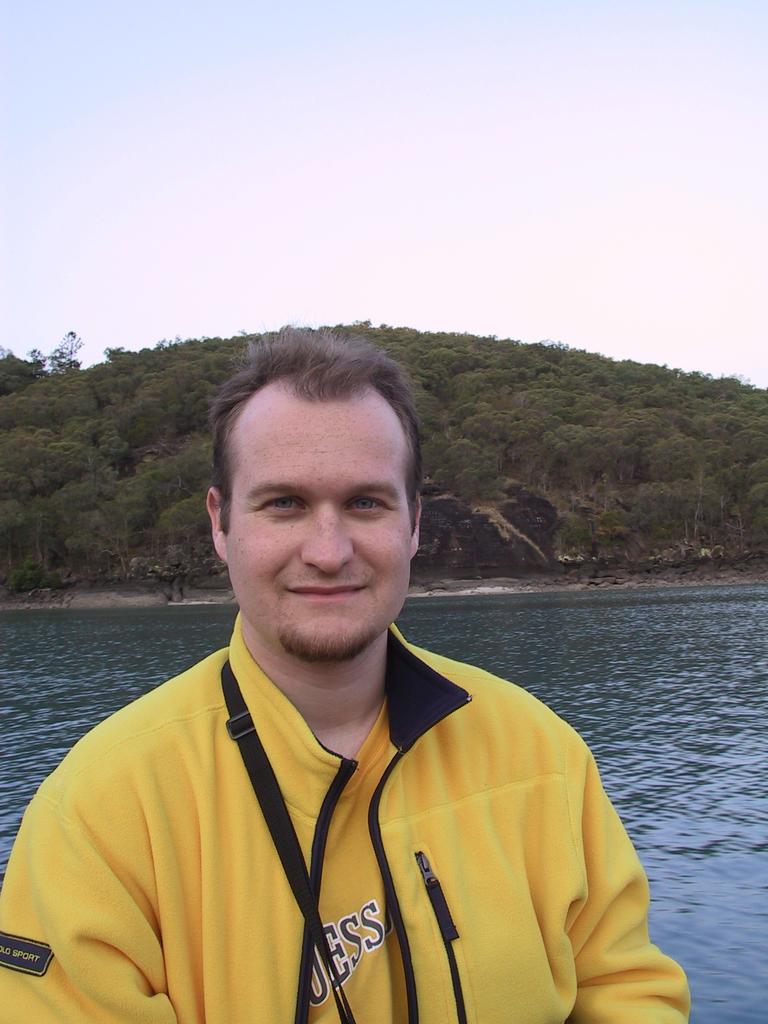What full word is written on the man's sleeve?
Your answer should be compact. Sport. What is the brand of top?
Provide a succinct answer. Guess. 